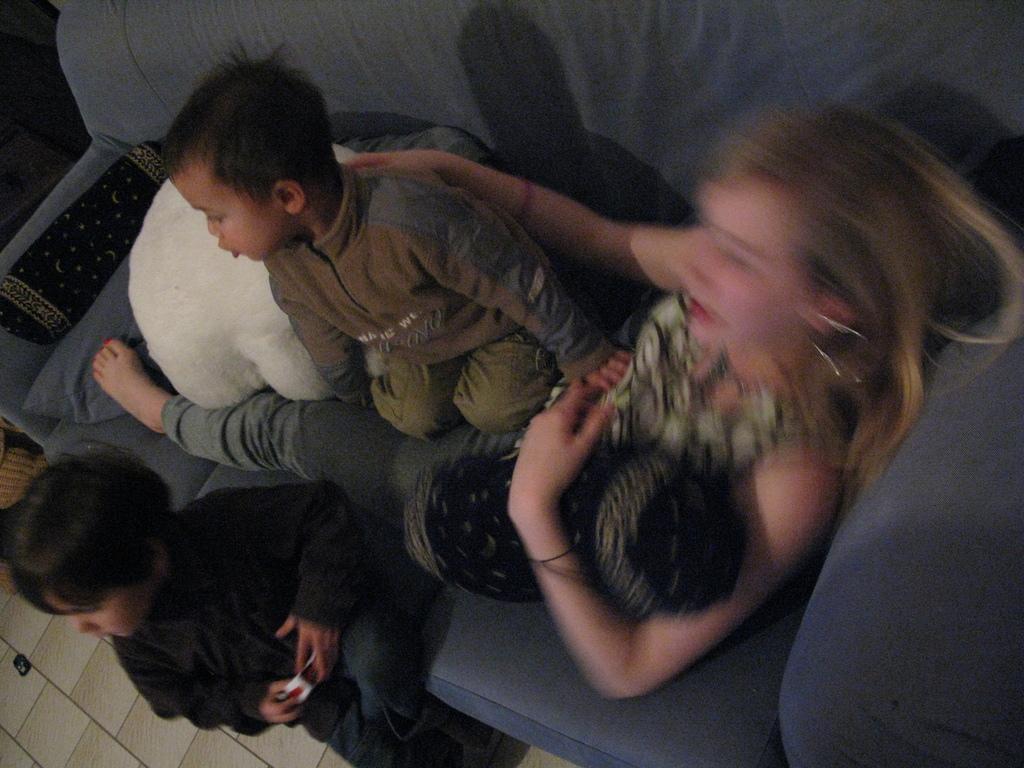How would you summarize this image in a sentence or two? In this image there is a sofa and we can see cushions placed on the sofa. There is a lady and two kids sitting on the sofa. At the bottom there is a floor. 